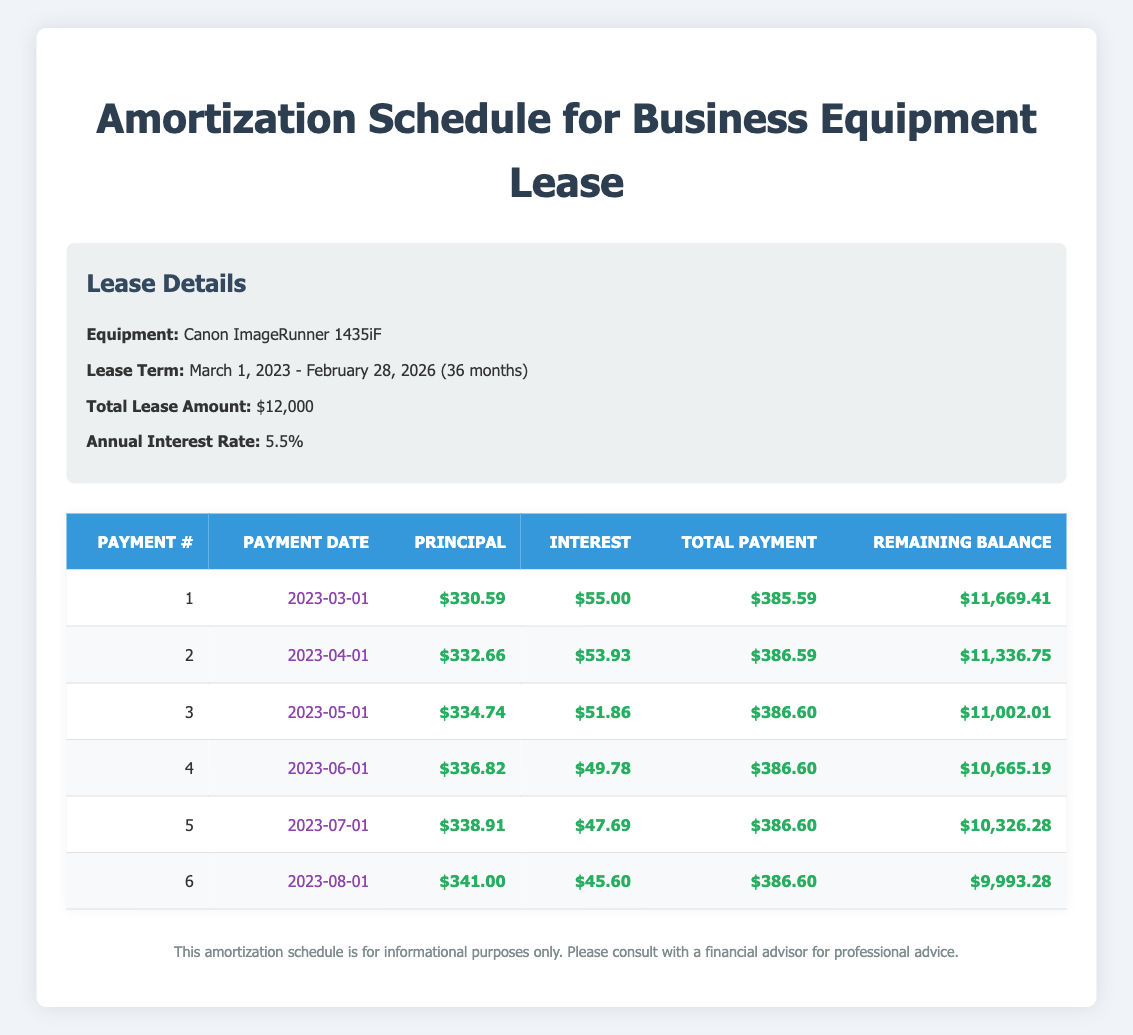What is the total payment for the first month? The total payment for the first month can be found in the first row of the payment schedule. It shows that the total payment made on 2023-03-01 is $385.59.
Answer: 385.59 What is the principal payment in the fourth month? The principal payment for the fourth month can be found in the fourth row of the payment schedule. It indicates that the principal payment made on 2023-06-01 is $336.82.
Answer: 336.82 How much interest is paid in total over the first six months? To find the total interest paid, sum the interest payments for each of the first six months: 55.00 + 53.93 + 51.86 + 49.78 + 47.69 + 45.60 = 303.76.
Answer: 303.76 Is the total payment for the second month greater than the total payment for the first month? The total payment for the second month is $386.59, which is greater than the total payment for the first month, which is $385.59. Therefore, the statement is true.
Answer: Yes What is the remaining balance after the sixth payment? The remaining balance after the sixth payment can be found in the sixth row of the payment schedule; it shows that the remaining balance on 2023-08-01 is $9,993.28.
Answer: 9,993.28 What was the average principal payment over the first six months? The average principal payment is calculated by summing the principal payments for the first six months and dividing by six: (330.59 + 332.66 + 334.74 + 336.82 + 338.91 + 341.00) / 6 = 336.12.
Answer: 336.12 What is the payment date for the fifth payment? The fifth payment date can be found in the fifth row of the payment schedule. It shows that the payment date is 2023-07-01.
Answer: 2023-07-01 Which month had the lowest interest payment, and what was the amount? The lowest interest payment can be identified by looking through the interest payments for each month. The month with the lowest interest payment is the sixth month (2023-08-01) with an interest payment of $45.60.
Answer: 45.60 What is the difference in remaining balance between the first and third payments? The remaining balance after the first payment is $11,669.41, and after the third payment, it is $11,002.01. The difference is $11,669.41 - $11,002.01 = $667.40.
Answer: 667.40 